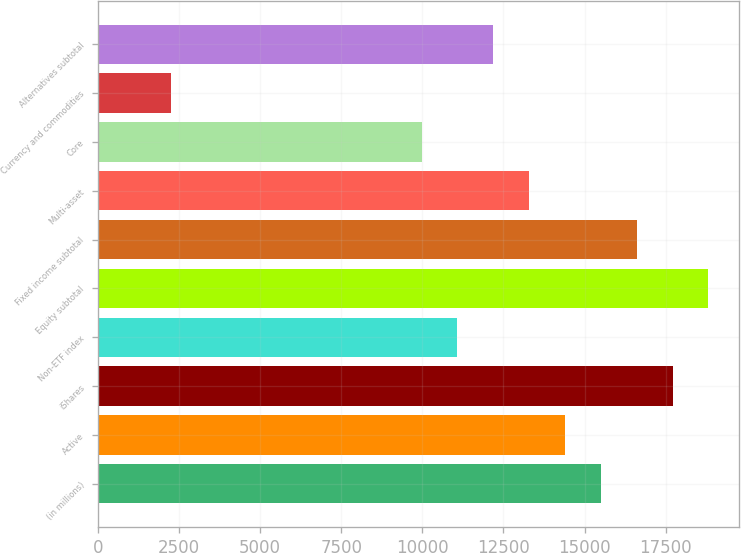Convert chart. <chart><loc_0><loc_0><loc_500><loc_500><bar_chart><fcel>(in millions)<fcel>Active<fcel>iShares<fcel>Non-ETF index<fcel>Equity subtotal<fcel>Fixed income subtotal<fcel>Multi-asset<fcel>Core<fcel>Currency and commodities<fcel>Alternatives subtotal<nl><fcel>15501<fcel>14396<fcel>17711<fcel>11081<fcel>18816<fcel>16606<fcel>13291<fcel>9976<fcel>2241<fcel>12186<nl></chart> 